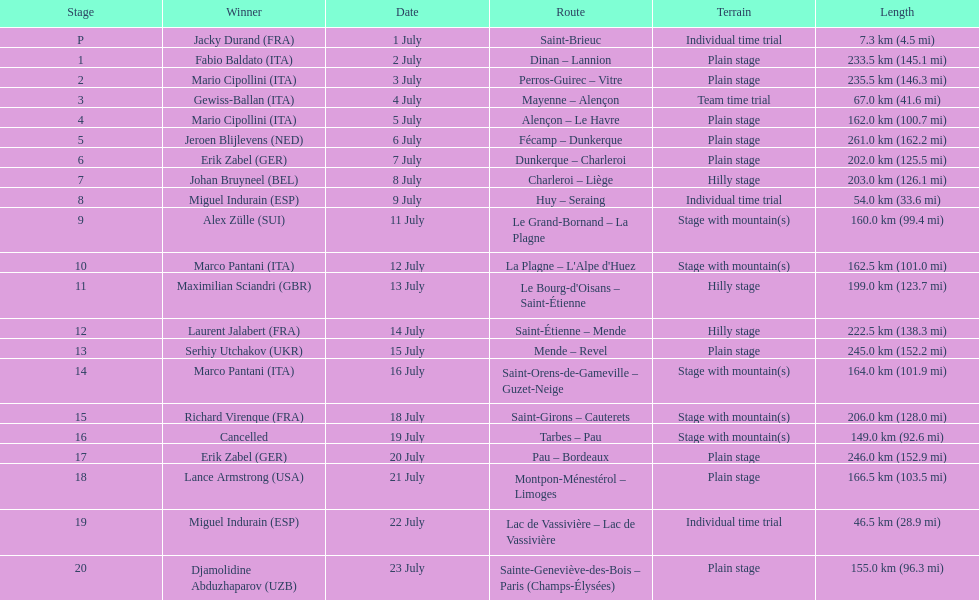How much longer is the 20th tour de france stage than the 19th? 108.5 km. 